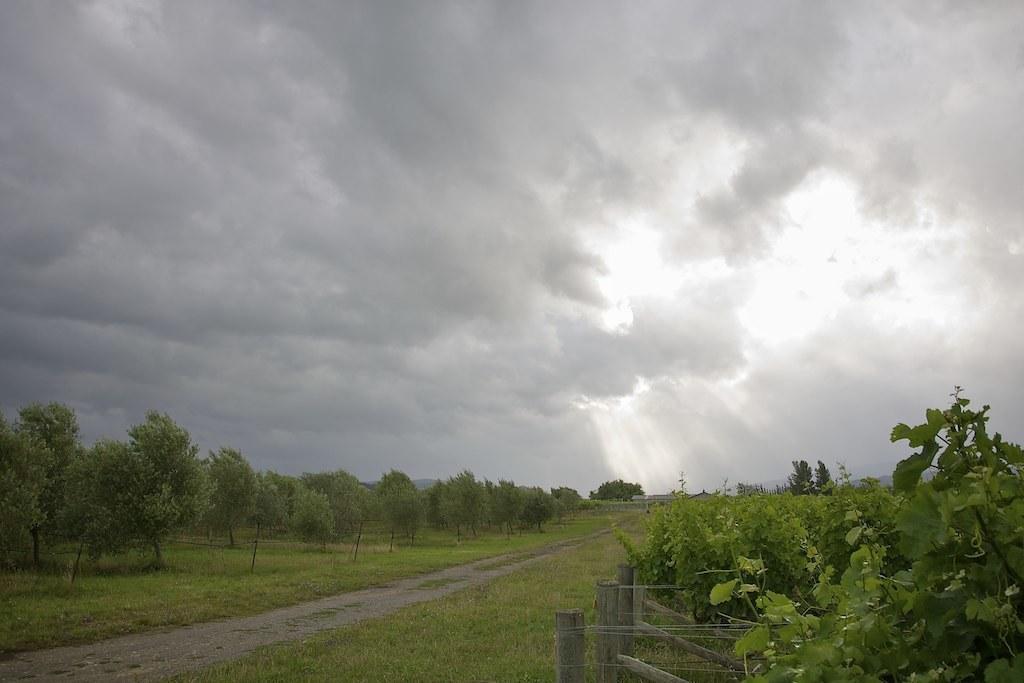Could you give a brief overview of what you see in this image? These are the left side of an image, at the top it's a cloudy sky. 